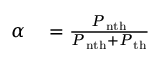Convert formula to latex. <formula><loc_0><loc_0><loc_500><loc_500>\begin{array} { r l } { \alpha } & = \frac { P _ { n t h } } { P _ { n t h } + P _ { t h } } } \end{array}</formula> 